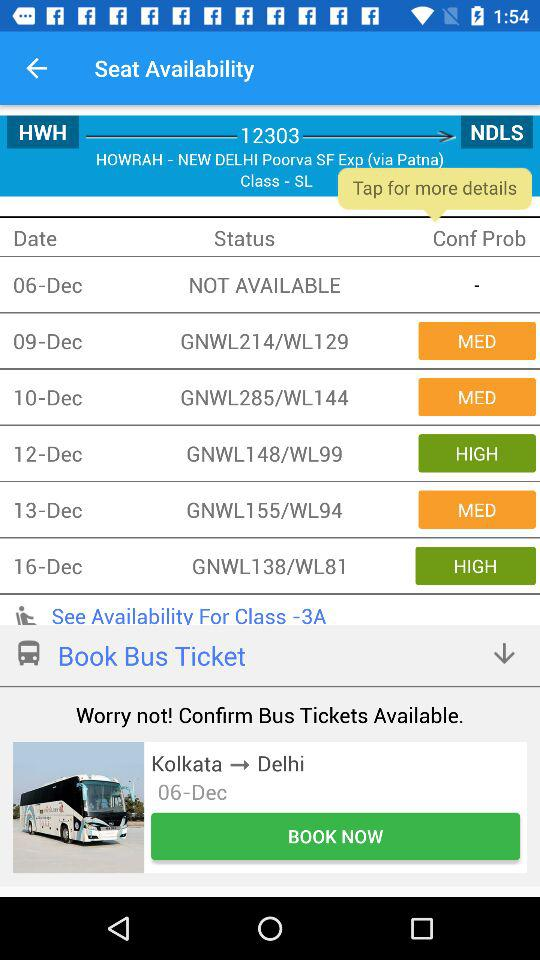What are the different statuses for Class-SL for different dates? The different statuses are "NOT AVAILABLE", "GNWL214/WL129", "GNWL285/WL144", "GNWL148/WL99", "GNWL155/WL94" and "GNWL138/WL81". 